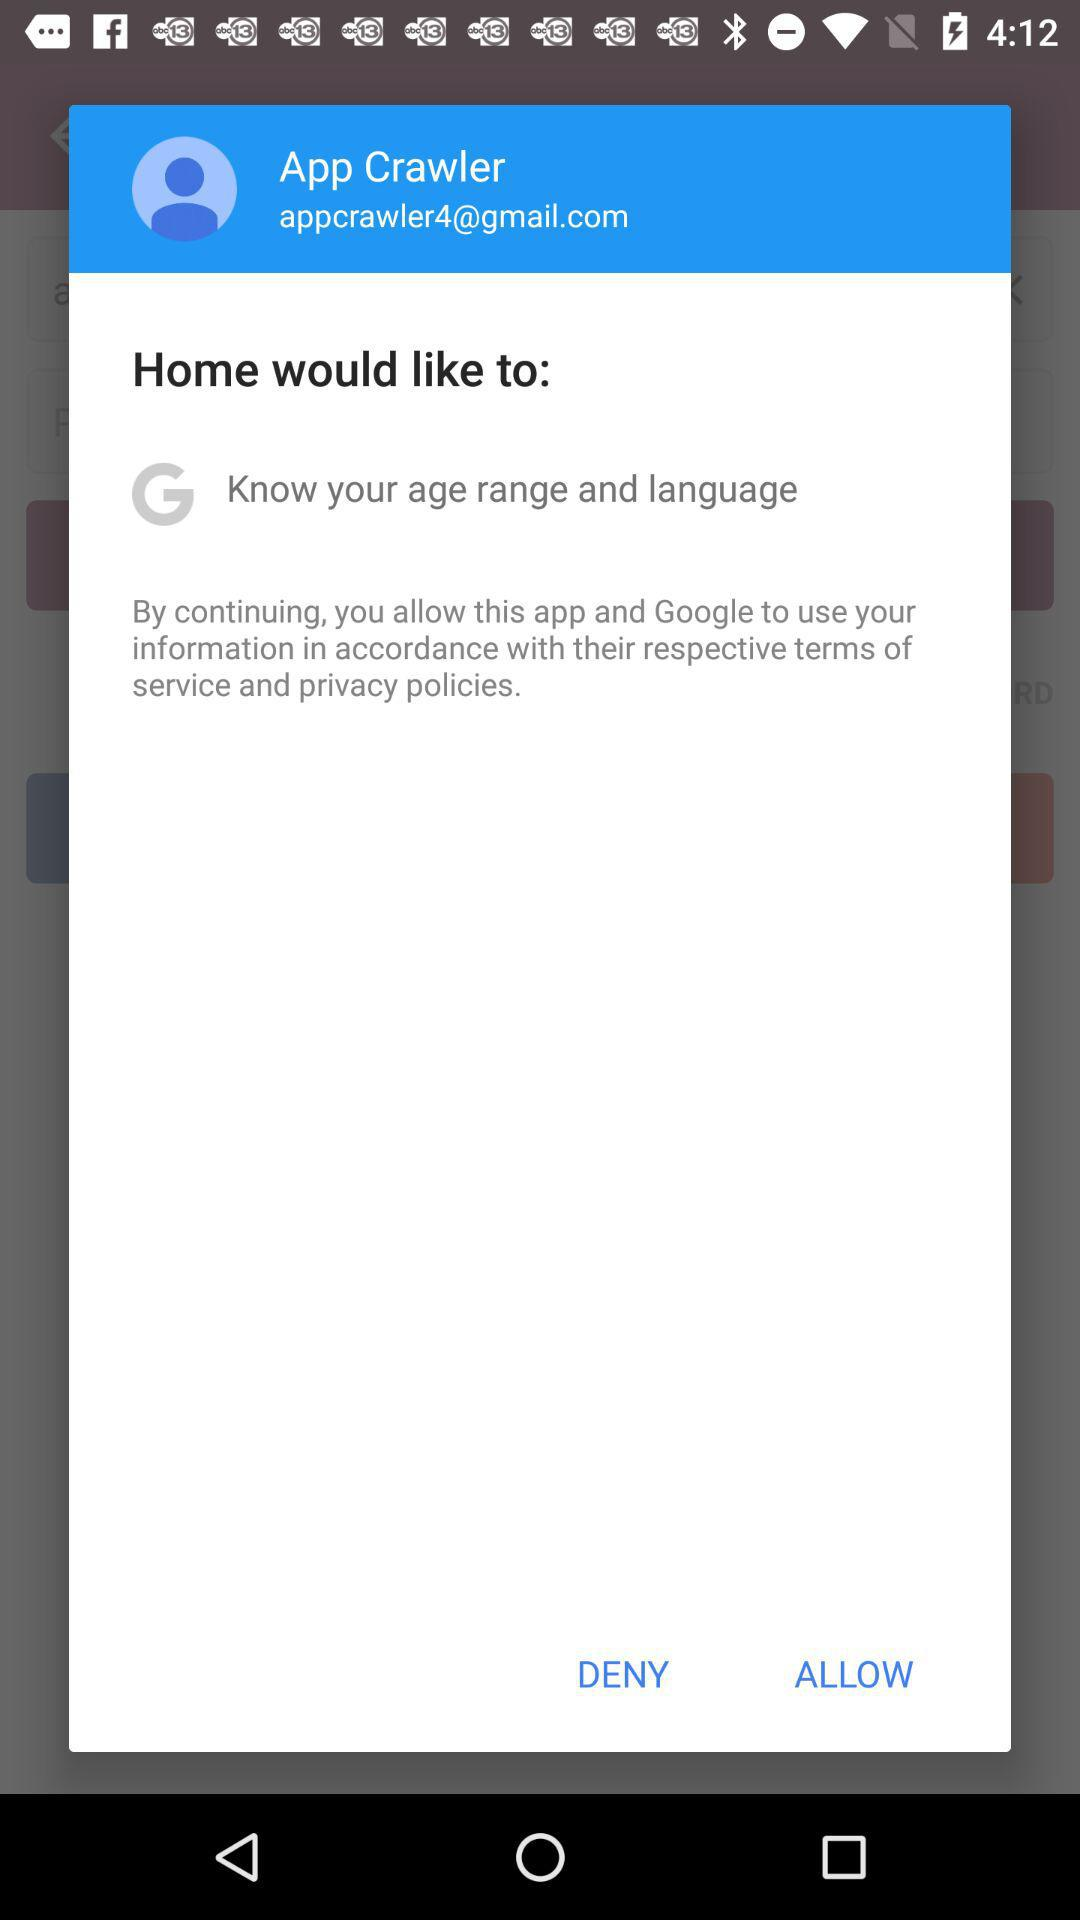What Gmail address is used? The Gmail address displayed in the image is appcrawler4@gmail.com, as shown prominently in the account information field. 